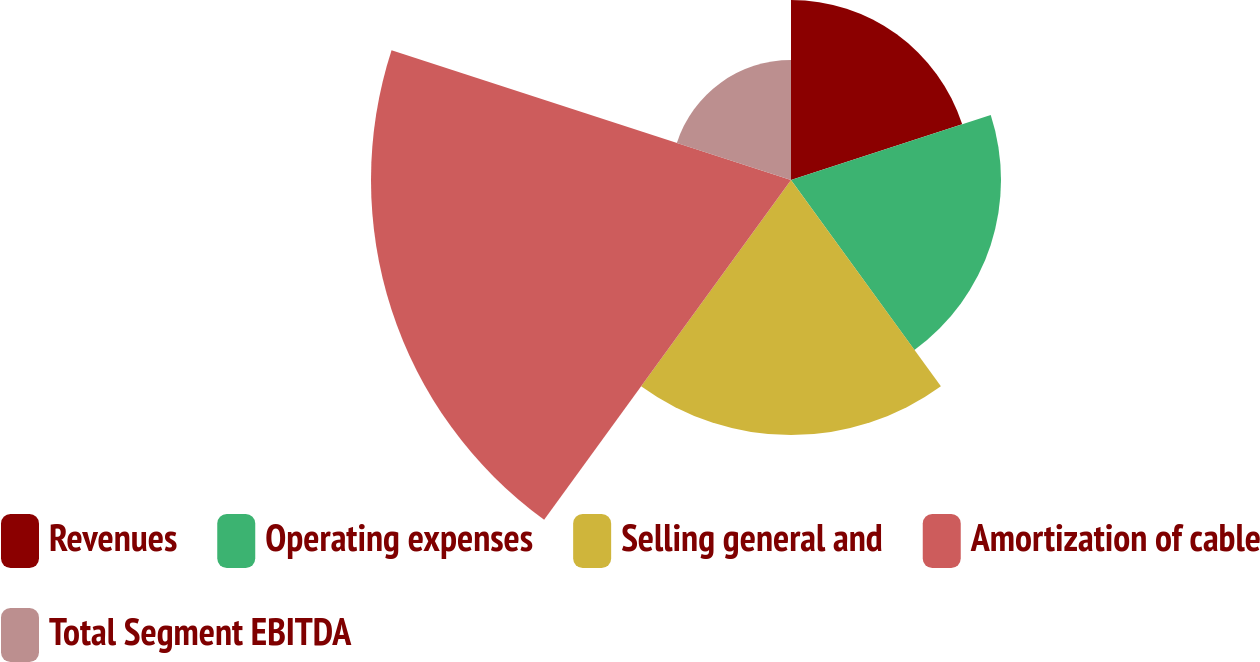Convert chart to OTSL. <chart><loc_0><loc_0><loc_500><loc_500><pie_chart><fcel>Revenues<fcel>Operating expenses<fcel>Selling general and<fcel>Amortization of cable<fcel>Total Segment EBITDA<nl><fcel>15.19%<fcel>17.72%<fcel>21.52%<fcel>35.44%<fcel>10.13%<nl></chart> 